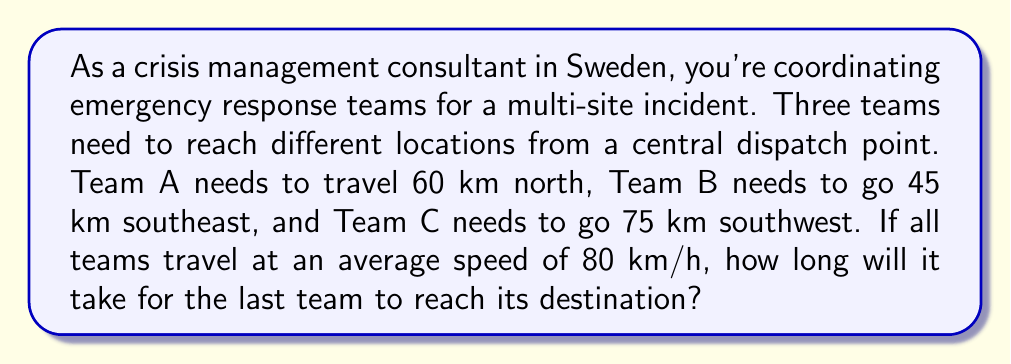Could you help me with this problem? Let's approach this step-by-step using the distance-rate-time equation:

$$\text{Time} = \frac{\text{Distance}}{\text{Rate}}$$

1. For Team A:
   $$t_A = \frac{60 \text{ km}}{80 \text{ km/h}} = 0.75 \text{ hours}$$

2. For Team B:
   $$t_B = \frac{45 \text{ km}}{80 \text{ km/h}} = 0.5625 \text{ hours}$$

3. For Team C:
   $$t_C = \frac{75 \text{ km}}{80 \text{ km/h}} = 0.9375 \text{ hours}$$

4. To find the time for the last team to reach its destination, we need to find the maximum of these three times:

   $$\max(t_A, t_B, t_C) = \max(0.75, 0.5625, 0.9375) = 0.9375 \text{ hours}$$

5. Convert 0.9375 hours to minutes:
   $$0.9375 \text{ hours} \times 60 \text{ minutes/hour} = 56.25 \text{ minutes}$$

Therefore, it will take 56.25 minutes for the last team (Team C) to reach its destination.
Answer: 56.25 minutes 